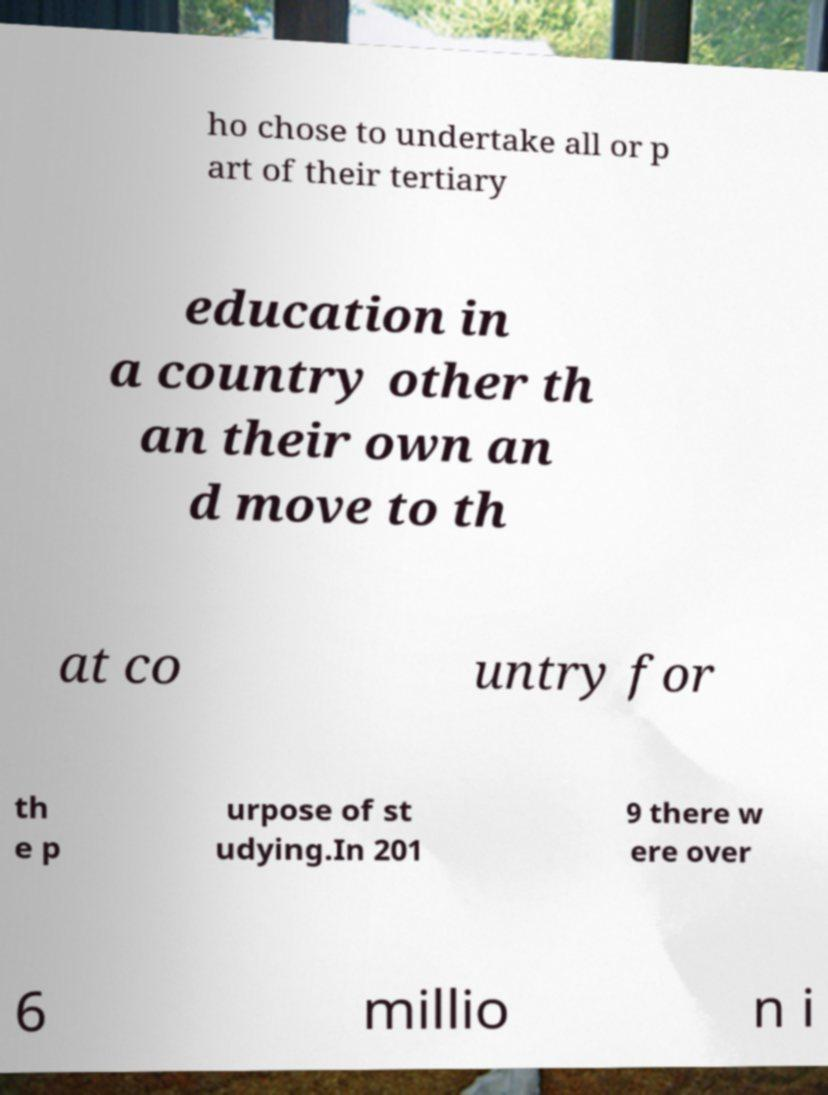Could you extract and type out the text from this image? ho chose to undertake all or p art of their tertiary education in a country other th an their own an d move to th at co untry for th e p urpose of st udying.In 201 9 there w ere over 6 millio n i 